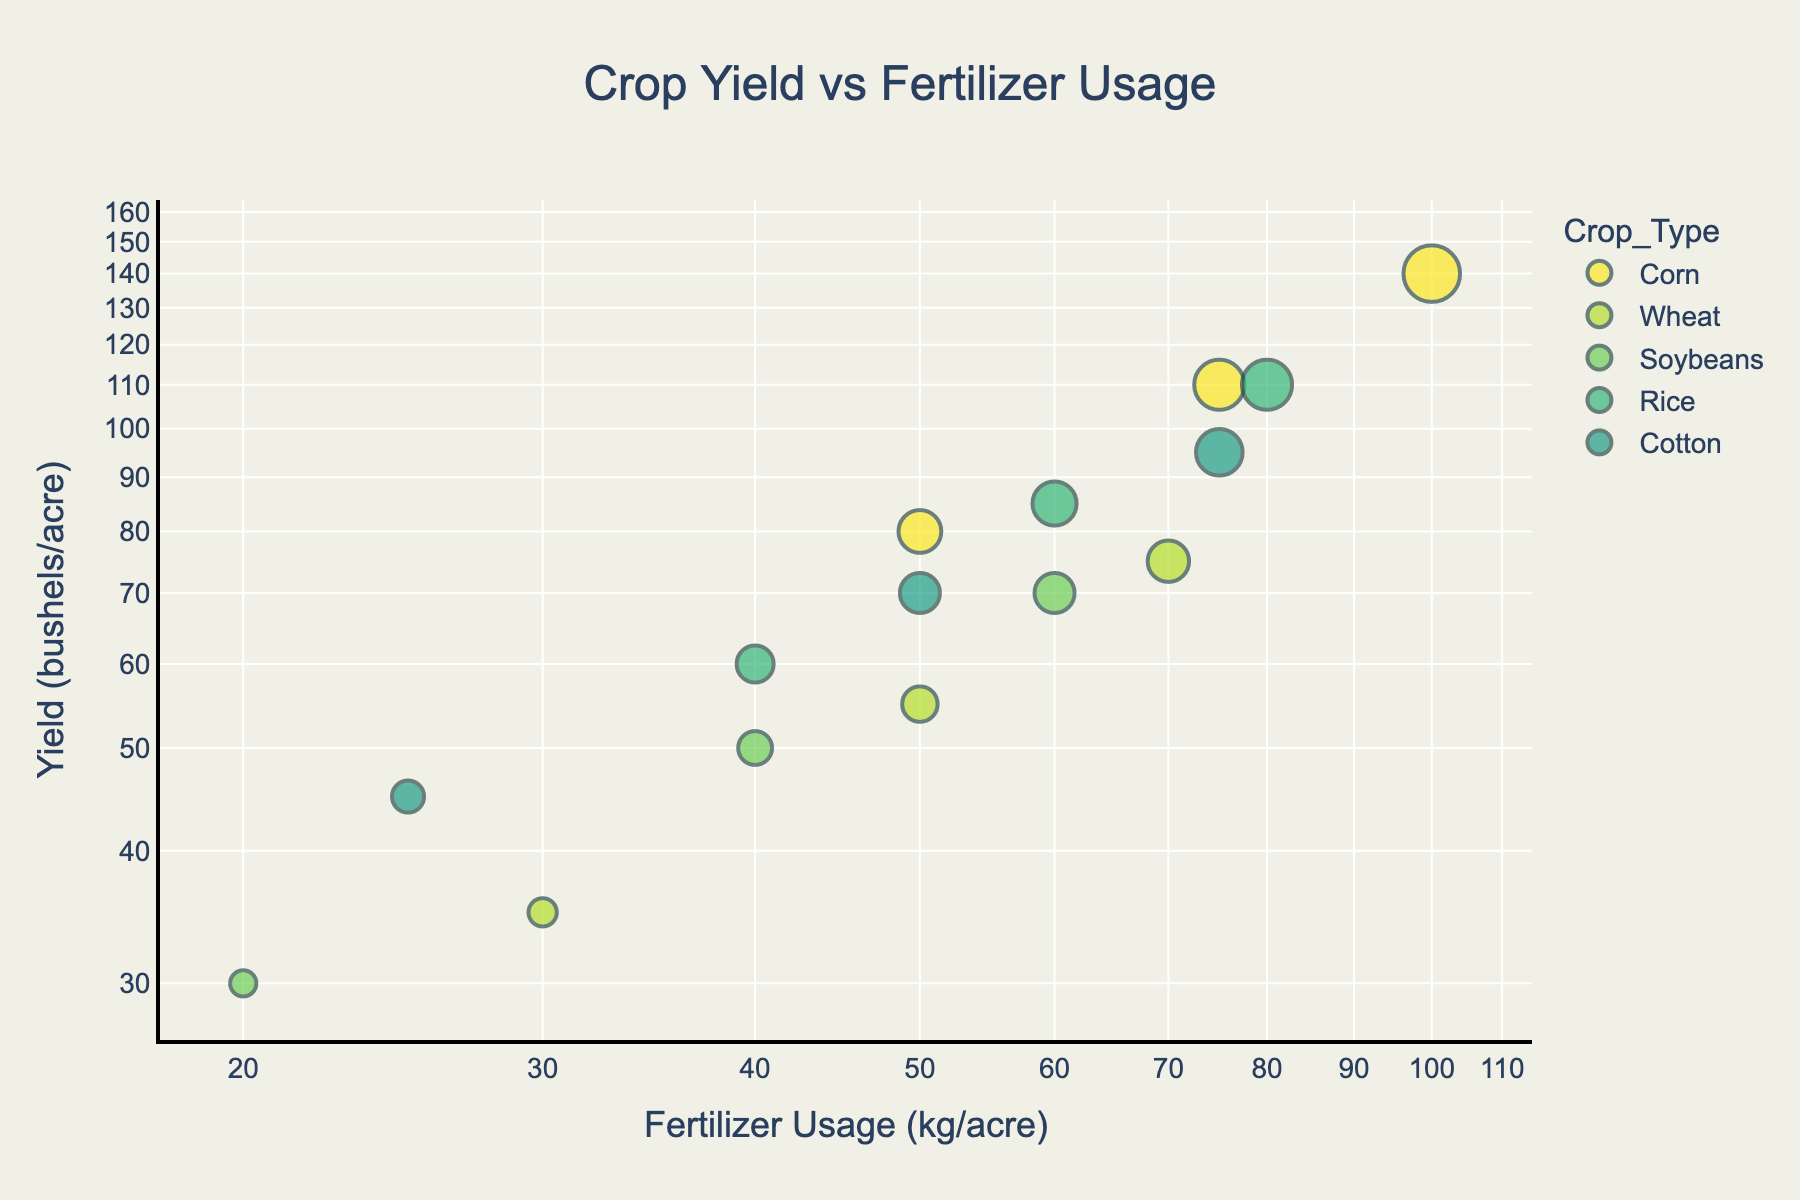What is the title of the figure? The title of the figure is located at the top. It summarizes the content of the plot.
Answer: Crop Yield vs Fertilizer Usage What are the axes labels in the plot? The axes labels provide information about what is being measured. The x-axis represents fertilizer usage in kg per acre, and the y-axis represents yield in bushels per acre.
Answer: Fertilizer Usage (kg/acre) and Yield (bushels/acre) Which crop type has the highest yield per acre at the maximum fertilizer usage observed? To find this, look at the plot and identify the highest point on the y-axis for the rightmost value on the x-axis (maximum fertilizer usage).
Answer: Corn How many data points are there for each crop type? Count the number of points for each distinct color representing different crop types. Corn has 3 points, Wheat has 3 points, Soybeans have 3 points, Rice has 3 points, and Cotton has 3 points.
Answer: 3 for each crop type Which crop type yields the least when fertilizer usage is minimal? Identify the leftmost points of each crop type and compare their positions on the y-axis. The lowest on the y-axis at minimal fertilizer usage represents the least yield.
Answer: Soybeans What is the range of fertilizer usage for all crop types? Examine the x-axis to find the smallest and largest values of fertilizer usage provided by any data point. The minimum is 20 kg/acre, and the maximum is 100 kg/acre.
Answer: 20 to 100 kg/acre Do all crop types show an increase in yield with increased fertilizer usage? To determine this, observe the trend of points for each crop type. If points for each crop move upwards on the y-axis with increasing x-axis values, the crops show an increasing yield.
Answer: Yes Between Wheat and Rice, which crop type shows a higher yield with 60 kg/acre of fertilizer? Locate the points for Wheat and Rice where the x-axis value is 60 kg/acre and compare their y-axis values (yield).
Answer: Rice What is the growth in yield for Cotton when fertilizer usage increases from 25 kg/acre to 50 kg/acre? Identify the y-values for Cotton at 25 kg/acre (45 bushels/acre) and 50 kg/acre (70 bushels/acre) and calculate the difference, which is 70 - 45.
Answer: 25 bushels/acre Which crop type shows the most proportional increase in yield per unit increase of fertilizer usage? Analyze the steepness of the slopes formed by the points for each crop type. The crop type with the steepest slope exhibits the greatest proportional increase in yield.
Answer: Corn 